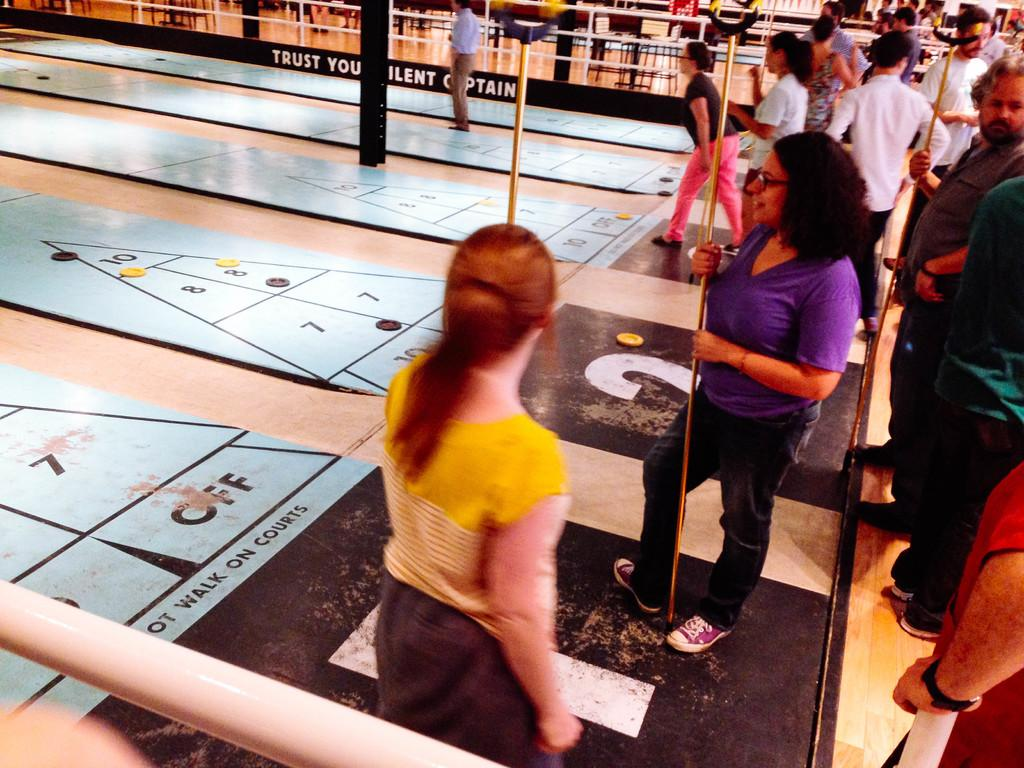What are the people in the image doing? The people in the image are playing a floor game. What are the people using to play the game? The people are holding sticks to play the game. What can be seen in the background of the image? There are chairs and tables in the background of the image. What type of pet is sitting on the manager's lap in the image? There is no manager or pet present in the image. How many curves can be seen in the floor game being played in the image? The floor game being played in the image does not involve any curves. 